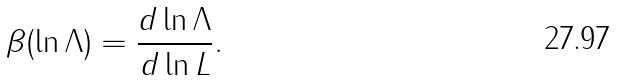<formula> <loc_0><loc_0><loc_500><loc_500>\beta ( \ln \Lambda ) = \frac { d \ln \Lambda } { d \ln L } .</formula> 